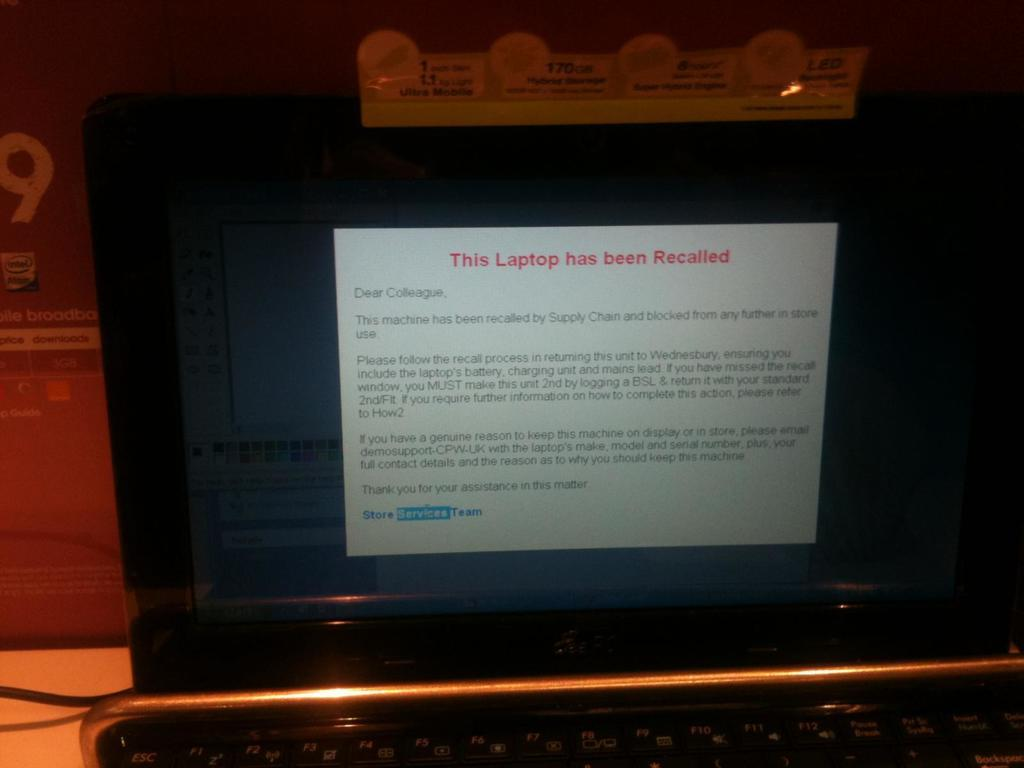Provide a one-sentence caption for the provided image. An open laptop with This laptop has been recalled written on the screen. 